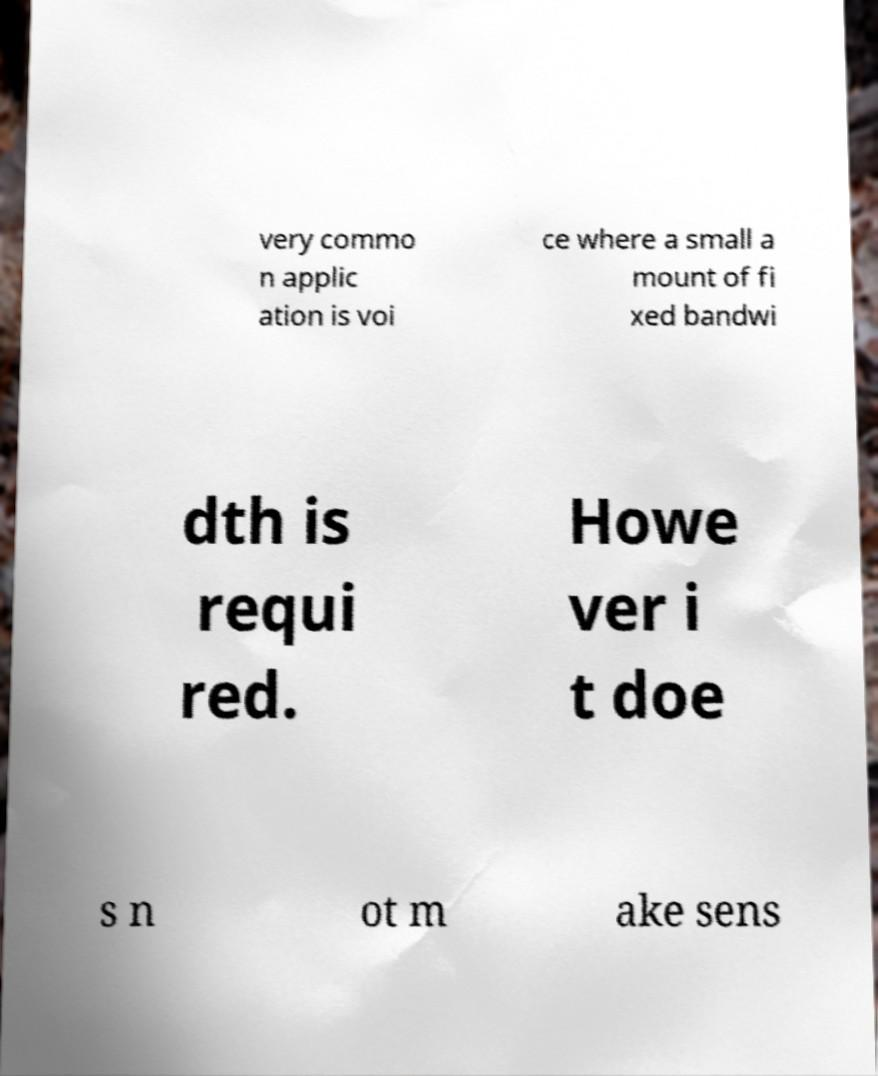Could you assist in decoding the text presented in this image and type it out clearly? very commo n applic ation is voi ce where a small a mount of fi xed bandwi dth is requi red. Howe ver i t doe s n ot m ake sens 